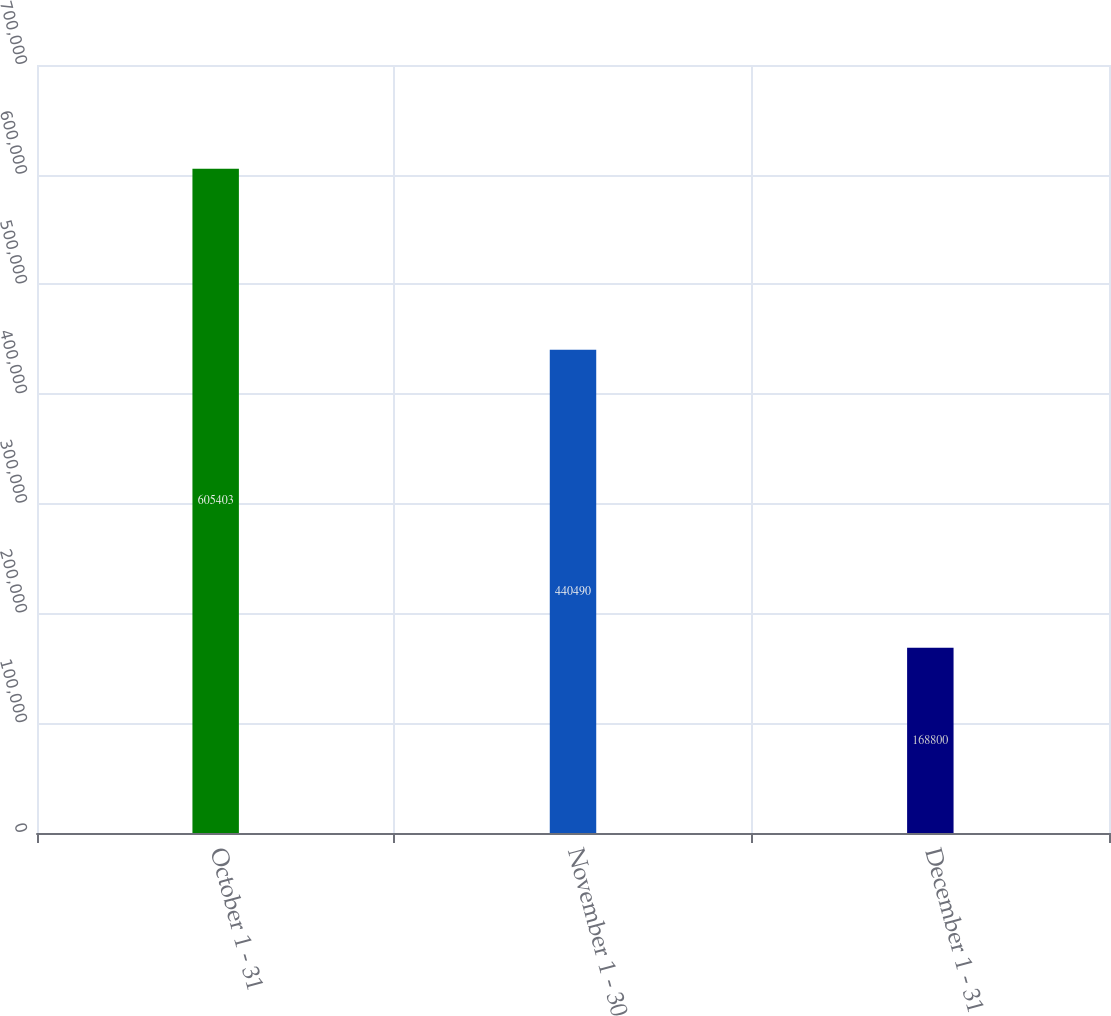Convert chart to OTSL. <chart><loc_0><loc_0><loc_500><loc_500><bar_chart><fcel>October 1 - 31<fcel>November 1 - 30<fcel>December 1 - 31<nl><fcel>605403<fcel>440490<fcel>168800<nl></chart> 